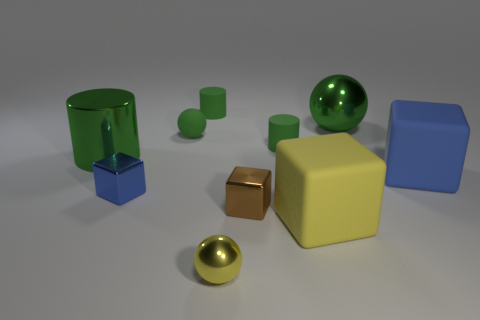Subtract all yellow cubes. How many cubes are left? 3 Subtract all blue cubes. How many cubes are left? 2 Subtract 3 blocks. How many blocks are left? 1 Subtract all large metallic things. Subtract all big yellow objects. How many objects are left? 7 Add 8 rubber cubes. How many rubber cubes are left? 10 Add 1 tiny purple rubber blocks. How many tiny purple rubber blocks exist? 1 Subtract 1 green cylinders. How many objects are left? 9 Subtract all cylinders. How many objects are left? 7 Subtract all purple cylinders. Subtract all red spheres. How many cylinders are left? 3 Subtract all gray blocks. How many yellow cylinders are left? 0 